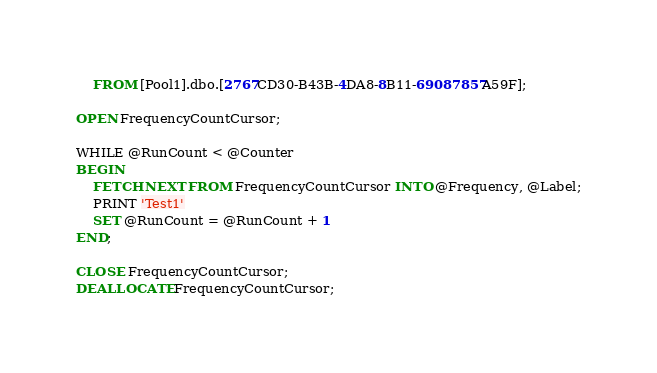Convert code to text. <code><loc_0><loc_0><loc_500><loc_500><_SQL_>	FROM [Pool1].dbo.[2767CD30-B43B-4DA8-8B11-69087857A59F];

OPEN FrequencyCountCursor;

WHILE @RunCount < @Counter
BEGIN
	FETCH NEXT FROM FrequencyCountCursor INTO @Frequency, @Label;
	PRINT 'Test1'
	SET @RunCount = @RunCount + 1
END;

CLOSE FrequencyCountCursor;
DEALLOCATE FrequencyCountCursor;</code> 